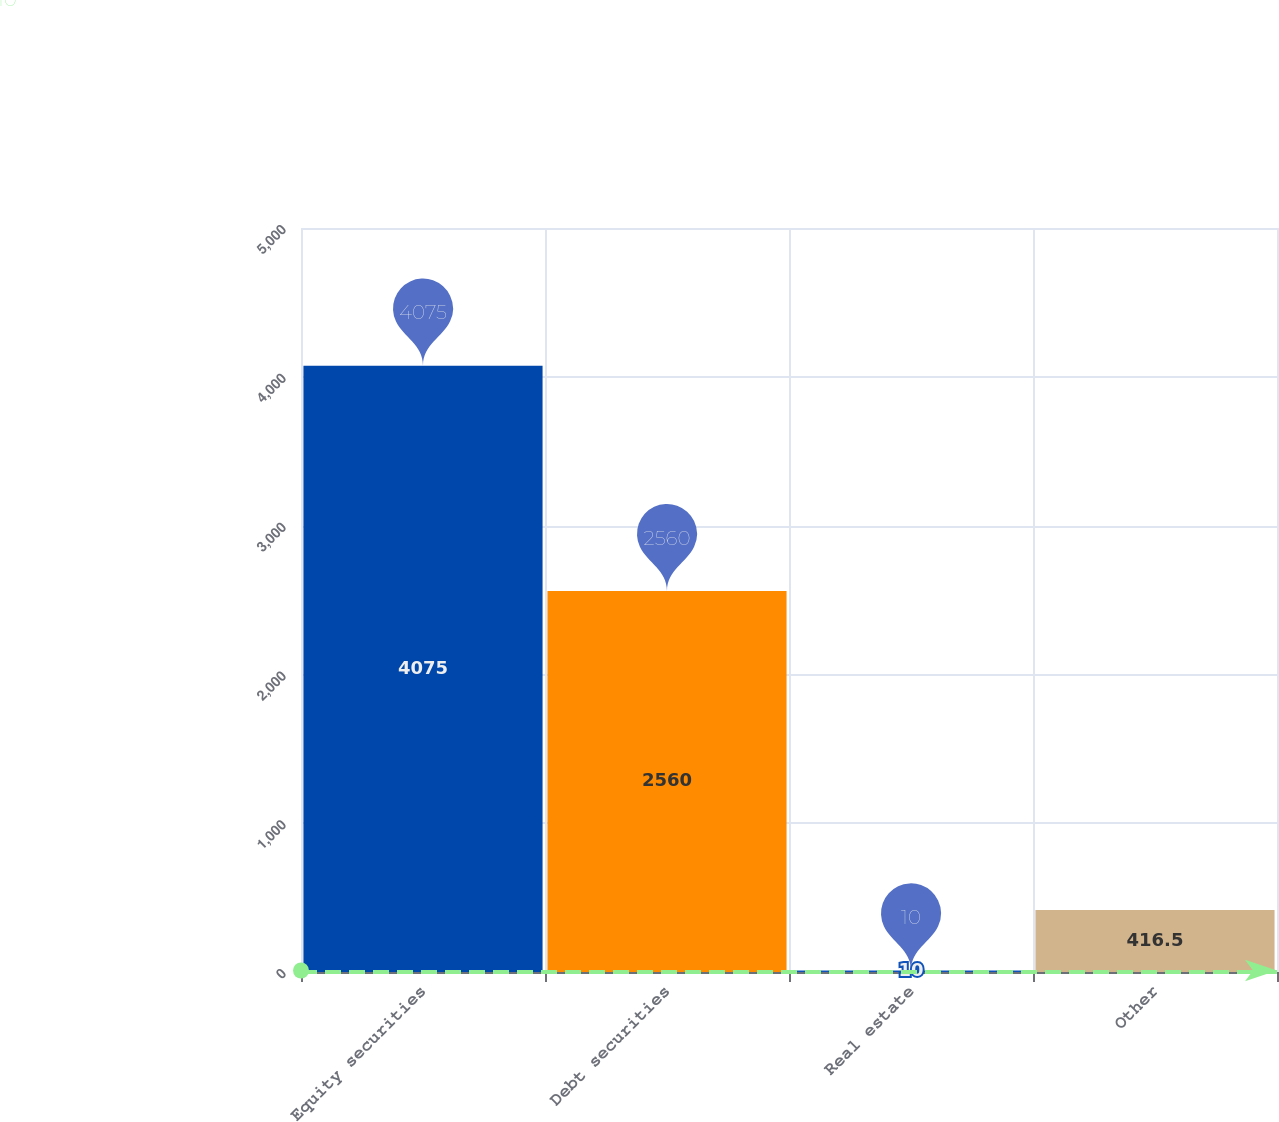Convert chart. <chart><loc_0><loc_0><loc_500><loc_500><bar_chart><fcel>Equity securities<fcel>Debt securities<fcel>Real estate<fcel>Other<nl><fcel>4075<fcel>2560<fcel>10<fcel>416.5<nl></chart> 